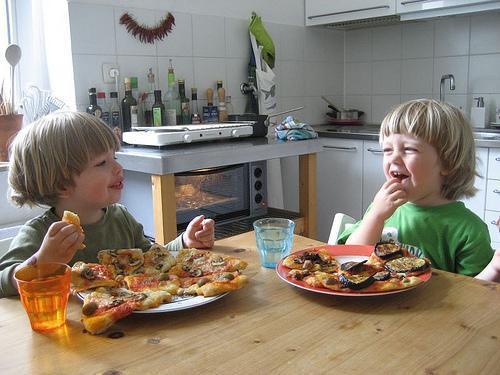How many people are there?
Give a very brief answer. 2. How many pizzas can you see?
Give a very brief answer. 2. 